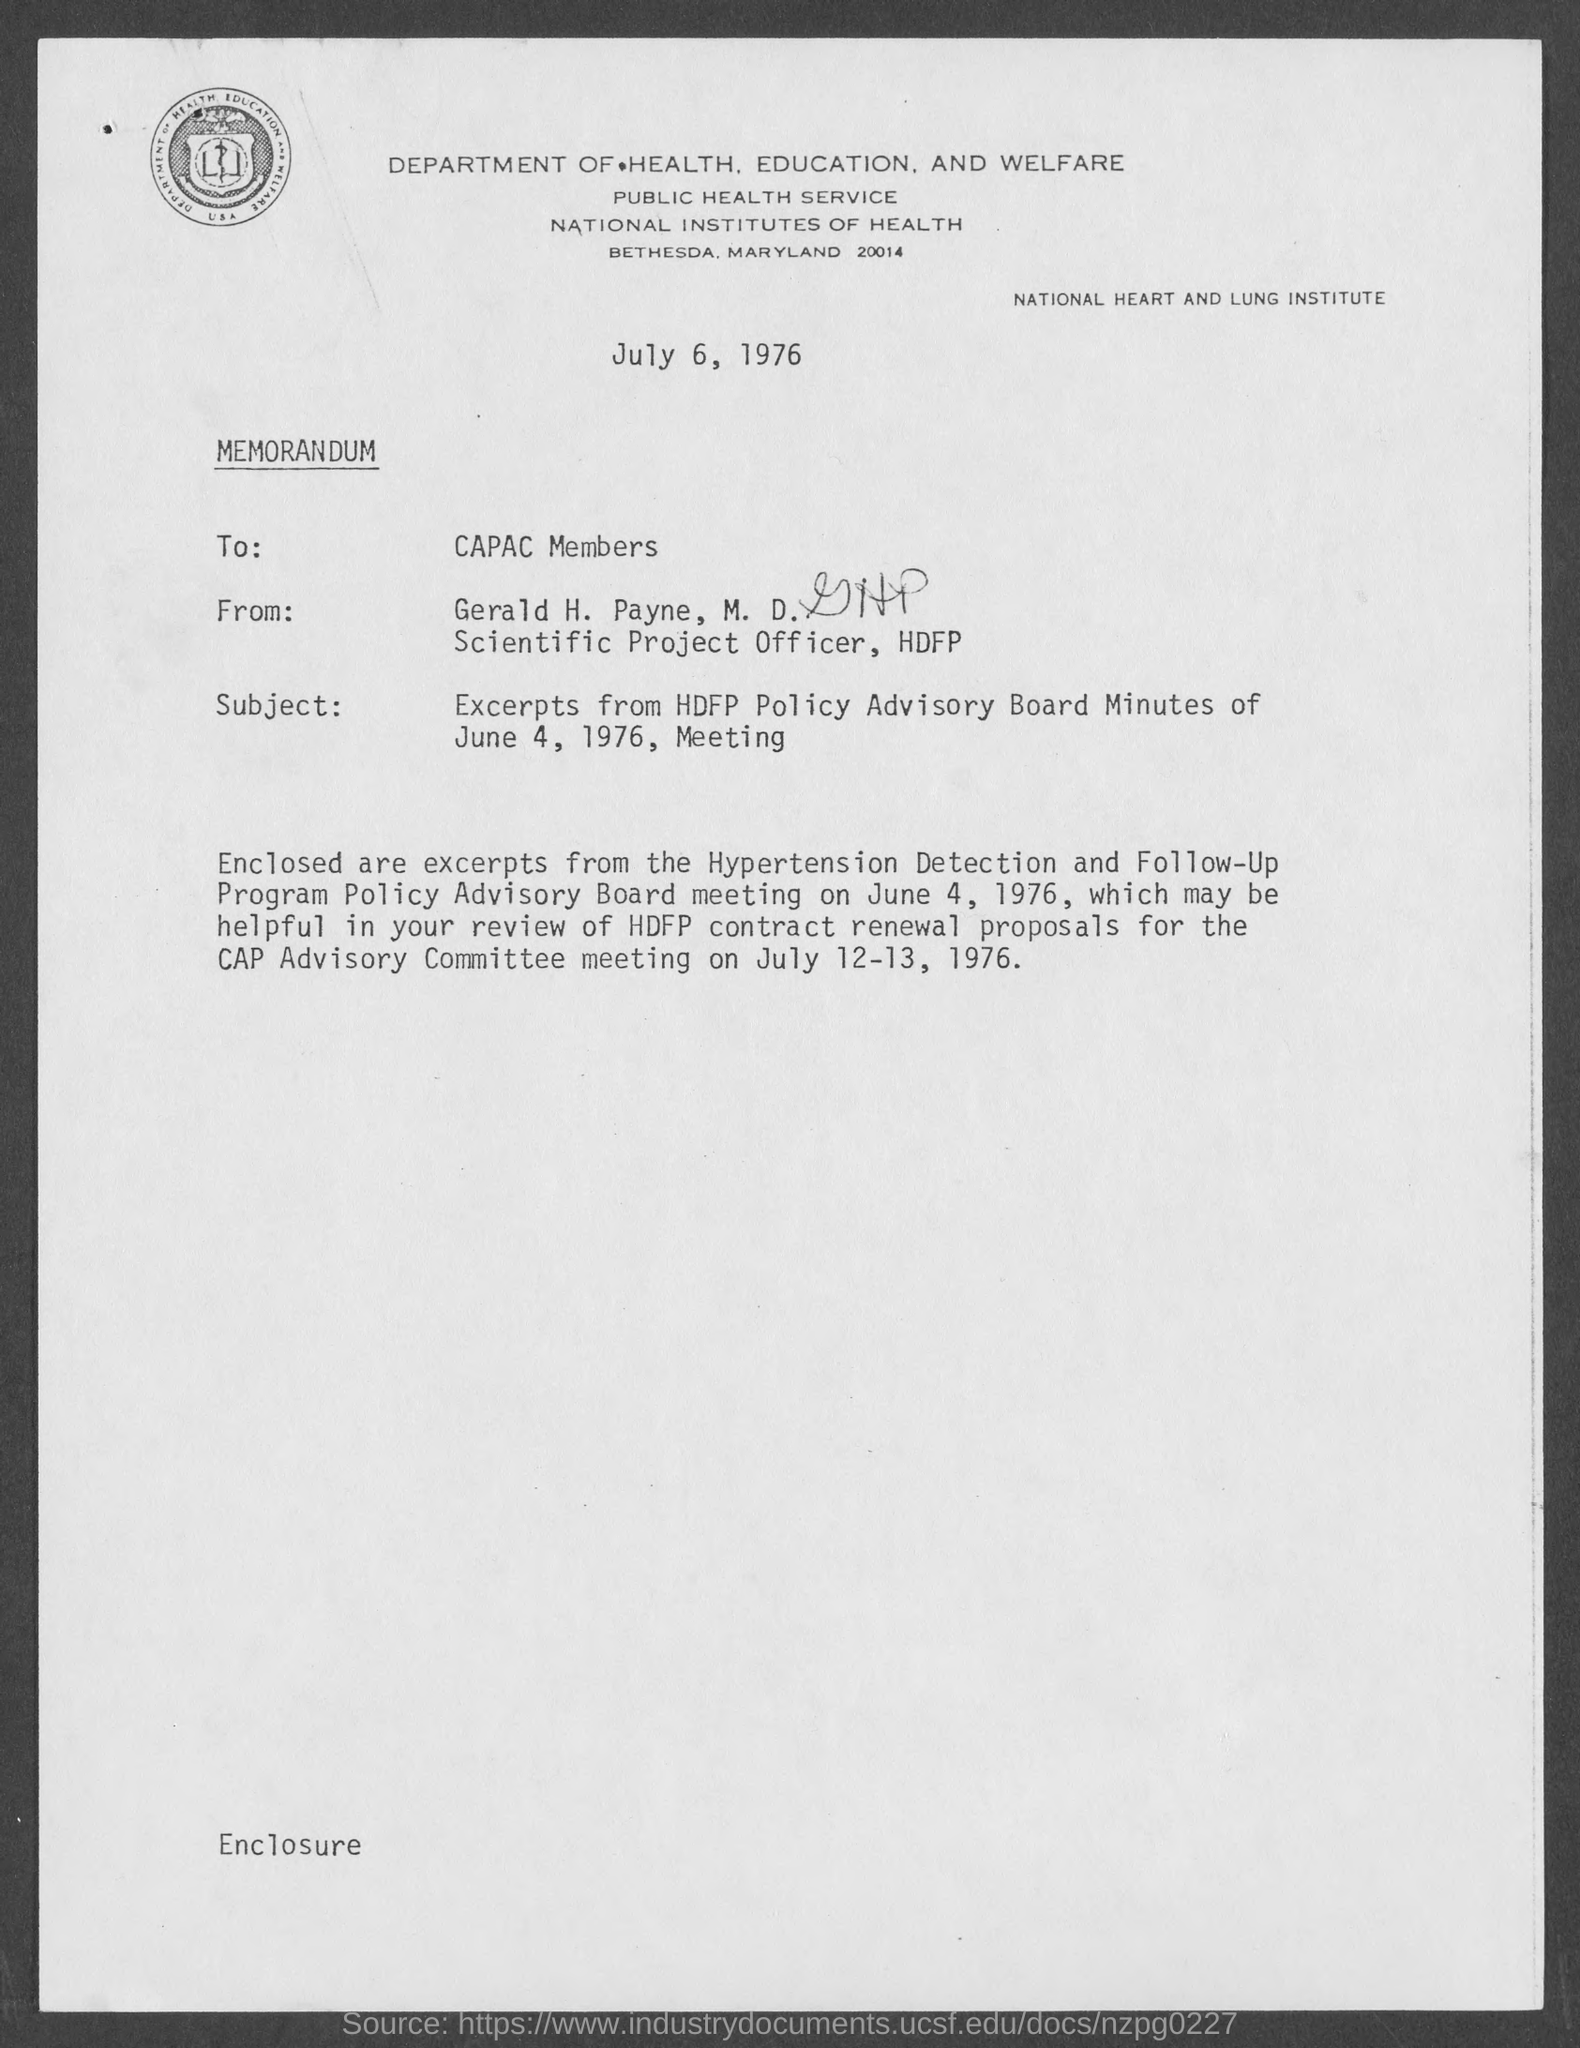What is the position of gerald h. payne, m.d.?
Make the answer very short. Scientific Project Officer. When is the memorandum dated?
Your response must be concise. July 6, 1976. When is the hypertension detection and follow- up program policy advisory board meeting on?
Offer a terse response. June 4, 1976. 